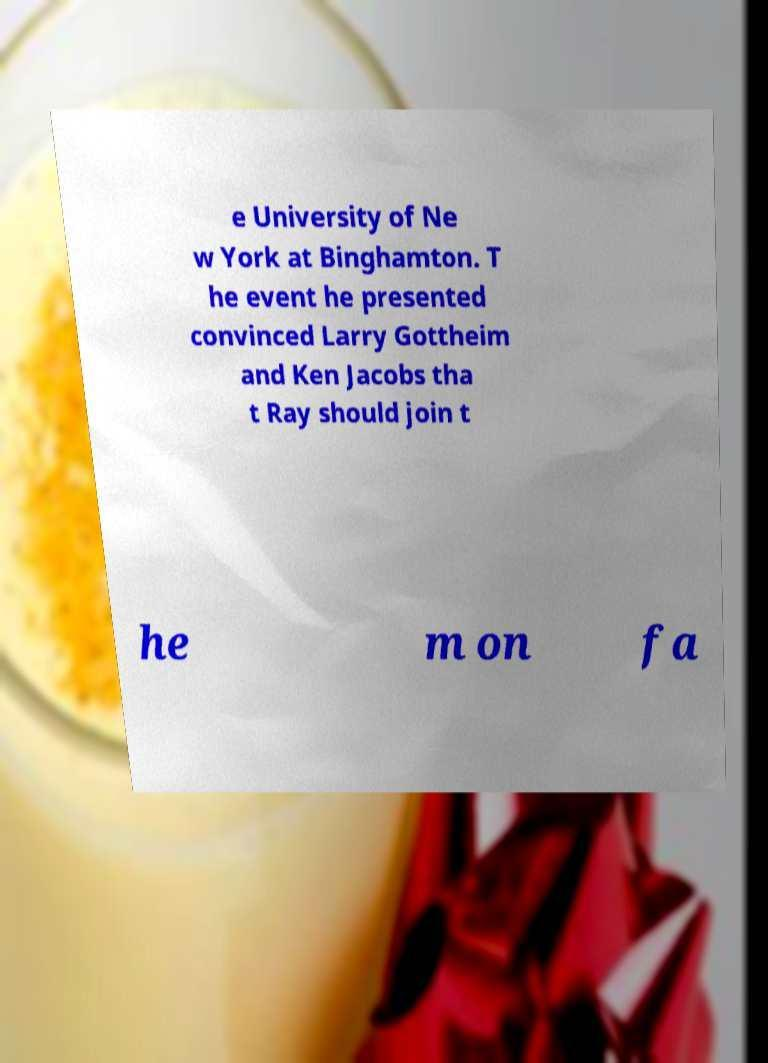Can you read and provide the text displayed in the image?This photo seems to have some interesting text. Can you extract and type it out for me? e University of Ne w York at Binghamton. T he event he presented convinced Larry Gottheim and Ken Jacobs tha t Ray should join t he m on fa 